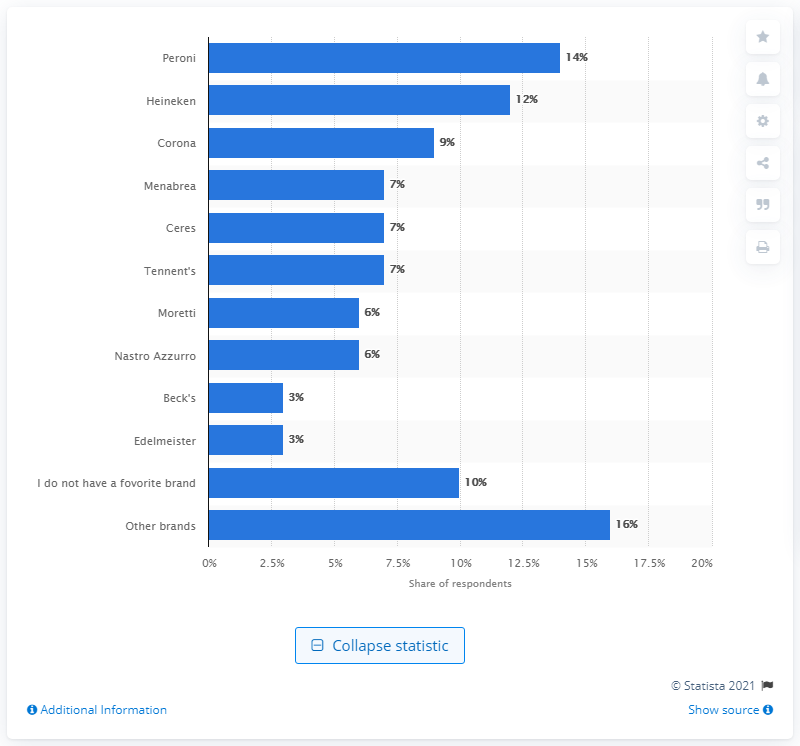Give some essential details in this illustration. Peroni was the most favored beer brand. 